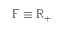<formula> <loc_0><loc_0><loc_500><loc_500>\mathbb { F } \equiv \mathbb { R } _ { + }</formula> 